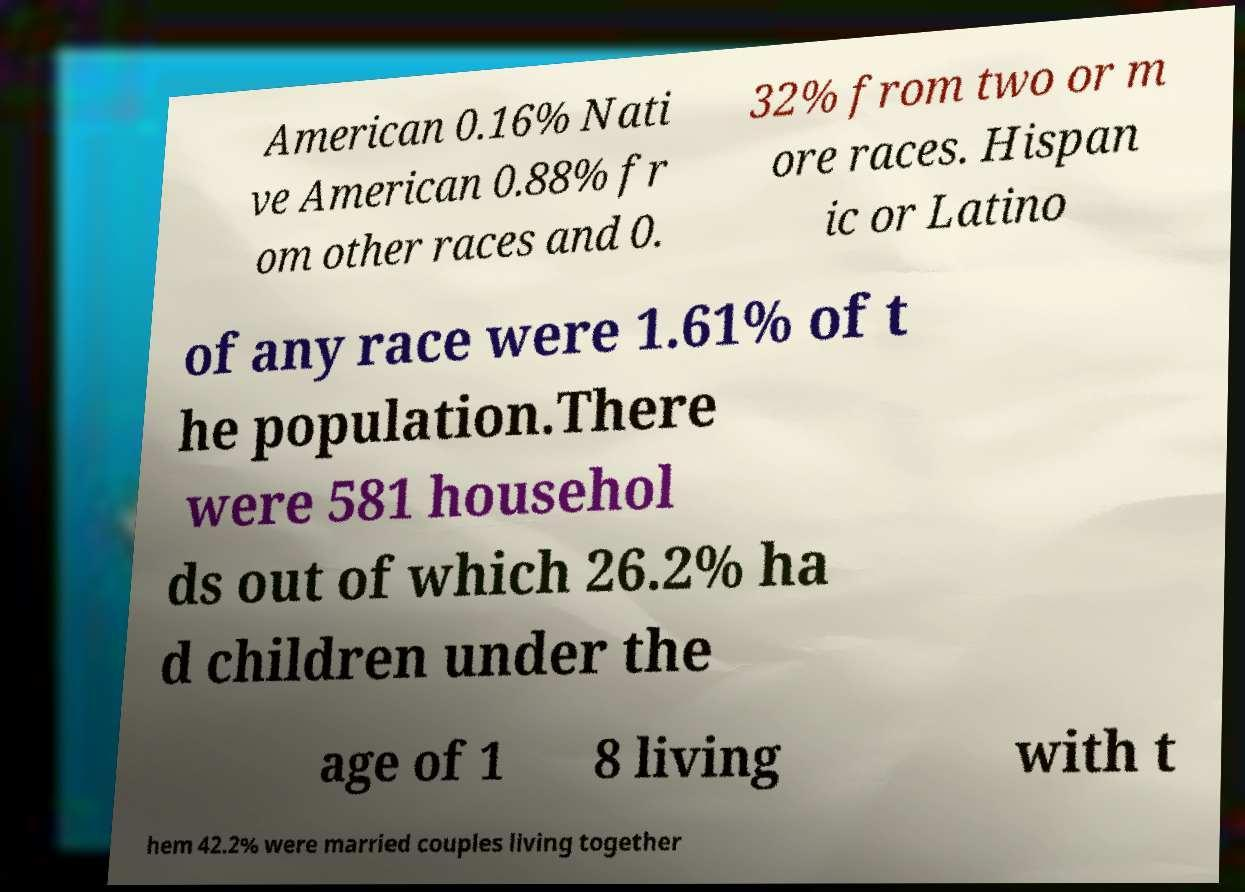Please read and relay the text visible in this image. What does it say? American 0.16% Nati ve American 0.88% fr om other races and 0. 32% from two or m ore races. Hispan ic or Latino of any race were 1.61% of t he population.There were 581 househol ds out of which 26.2% ha d children under the age of 1 8 living with t hem 42.2% were married couples living together 